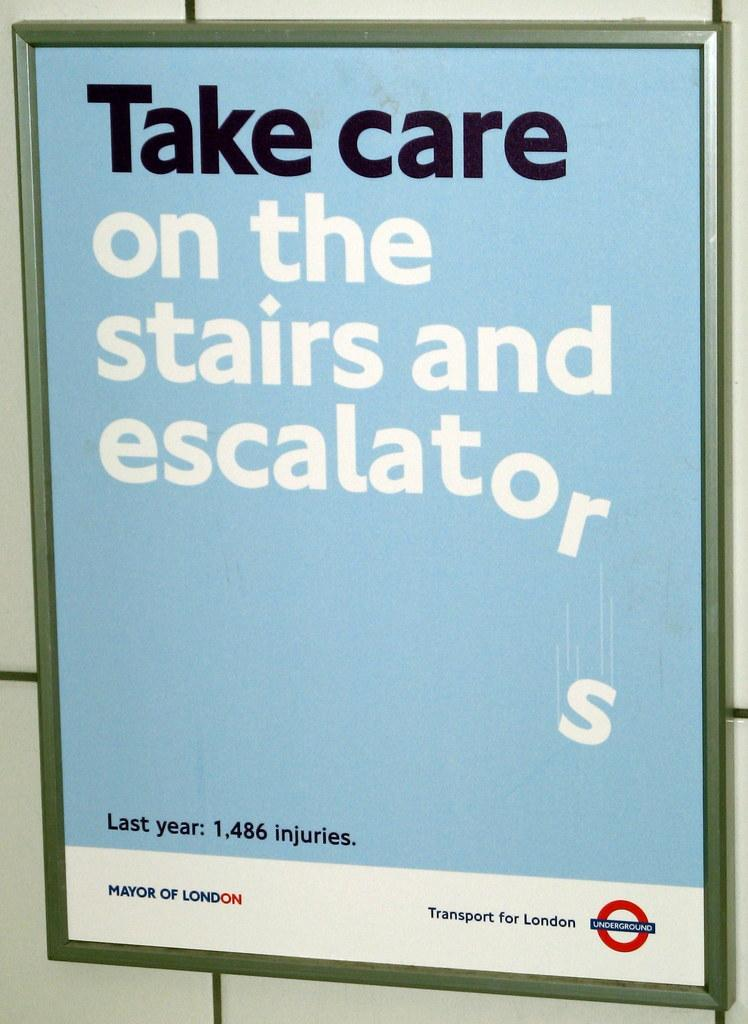<image>
Provide a brief description of the given image. A poster that says take care on the stairs and escalator from London. 